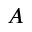<formula> <loc_0><loc_0><loc_500><loc_500>A</formula> 